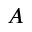<formula> <loc_0><loc_0><loc_500><loc_500>A</formula> 